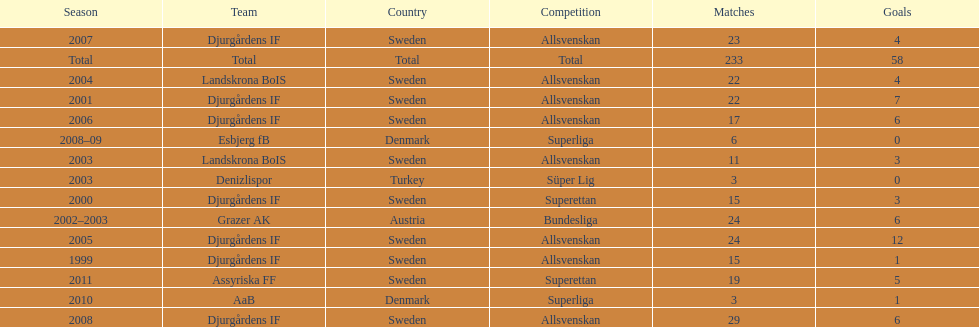How many total goals has jones kusi-asare scored? 58. 